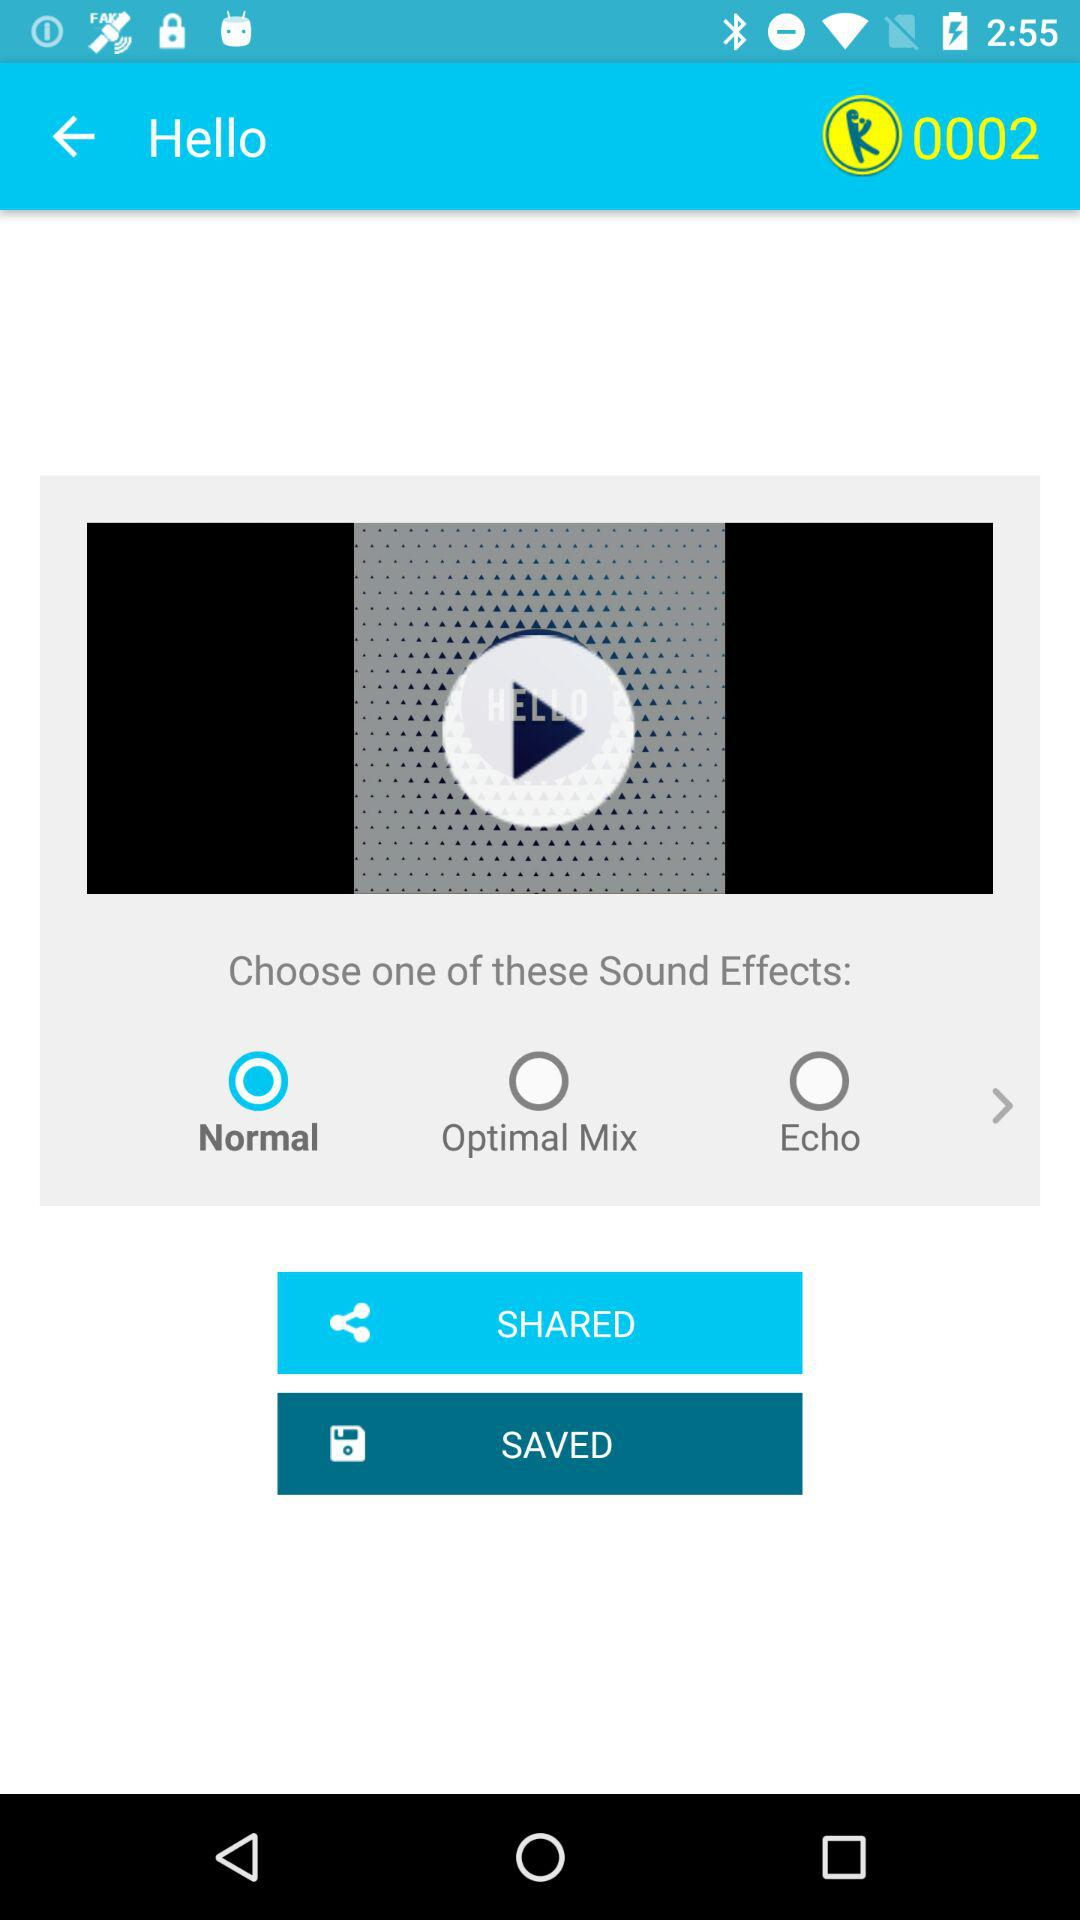How many sound effects are there?
Answer the question using a single word or phrase. 3 